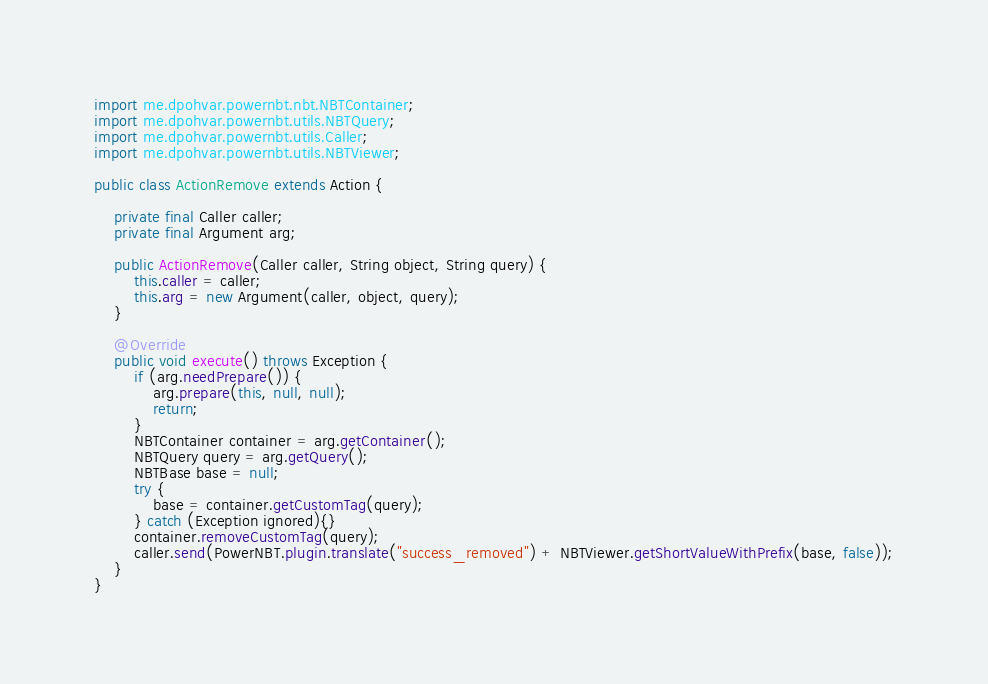Convert code to text. <code><loc_0><loc_0><loc_500><loc_500><_Java_>import me.dpohvar.powernbt.nbt.NBTContainer;
import me.dpohvar.powernbt.utils.NBTQuery;
import me.dpohvar.powernbt.utils.Caller;
import me.dpohvar.powernbt.utils.NBTViewer;

public class ActionRemove extends Action {

    private final Caller caller;
    private final Argument arg;

    public ActionRemove(Caller caller, String object, String query) {
        this.caller = caller;
        this.arg = new Argument(caller, object, query);
    }

    @Override
    public void execute() throws Exception {
        if (arg.needPrepare()) {
            arg.prepare(this, null, null);
            return;
        }
        NBTContainer container = arg.getContainer();
        NBTQuery query = arg.getQuery();
        NBTBase base = null;
        try {
            base = container.getCustomTag(query);
        } catch (Exception ignored){}
        container.removeCustomTag(query);
        caller.send(PowerNBT.plugin.translate("success_removed") + NBTViewer.getShortValueWithPrefix(base, false));
    }
}
</code> 